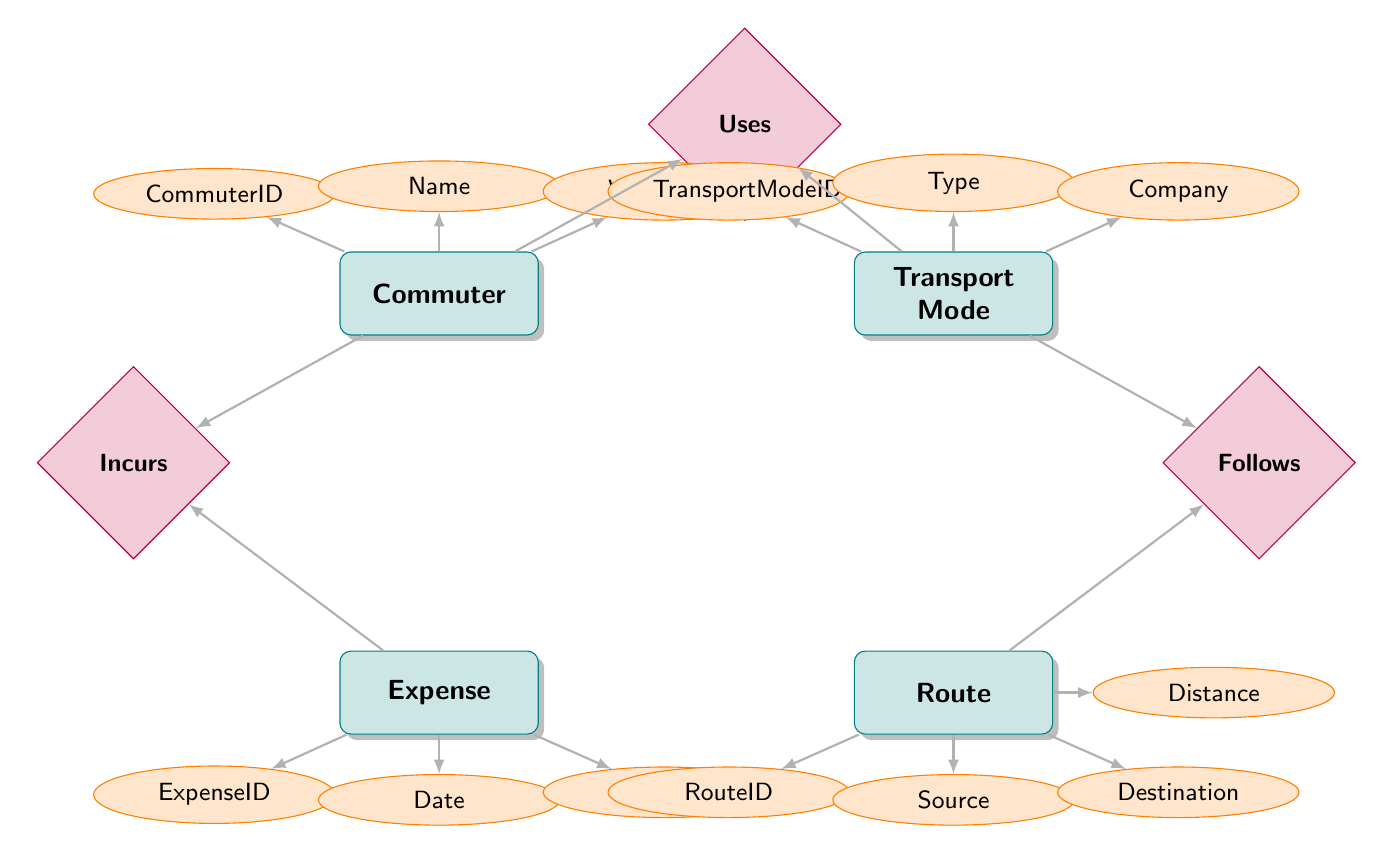What entities are present in the diagram? The diagram includes four entities: Commuter, Transport Mode, Expense, and Route.
Answer: Commuter, Transport Mode, Expense, Route How many relationships are there in the diagram? The diagram shows three relationships: Uses, Incurs, and Follows. We count them to find the total.
Answer: 3 What attribute is associated with the Commuter entity? The Commuter entity has three attributes: CommuterID, Name, and Workplace. Perusing the node reveals this information.
Answer: CommuterID, Name, Workplace Which entities are connected by the Uses relationship? The Uses relationship connects the Commuter and Transport Mode entities. This can be seen by tracing the line connecting the two.
Answer: Commuter, Transport Mode What is the preferred attribute in the Uses relationship? The Uses relationship contains a Preferred attribute along with Frequency. This is determining based on looking at the relationship attributes.
Answer: Preferred What transport mode has a company associated with it? The Transport Mode entity has an associated Company attribute, specifying the company that provides the transport.
Answer: Company How does a Commuter incur an Expense? A Commuter incurs an Expense through the Incurs relationship, which indicates a connection between these two entities.
Answer: Incurs What attribute indicates the Distance in the Route entity? The Route entity has an attribute called Distance, which measures the distance between Source and Destination.
Answer: Distance Which entity does the Follows relationship connect to Route? The Follows relationship connects the Transport Mode entity to the Route entity, showcasing how transport modes follow certain routes.
Answer: Route 